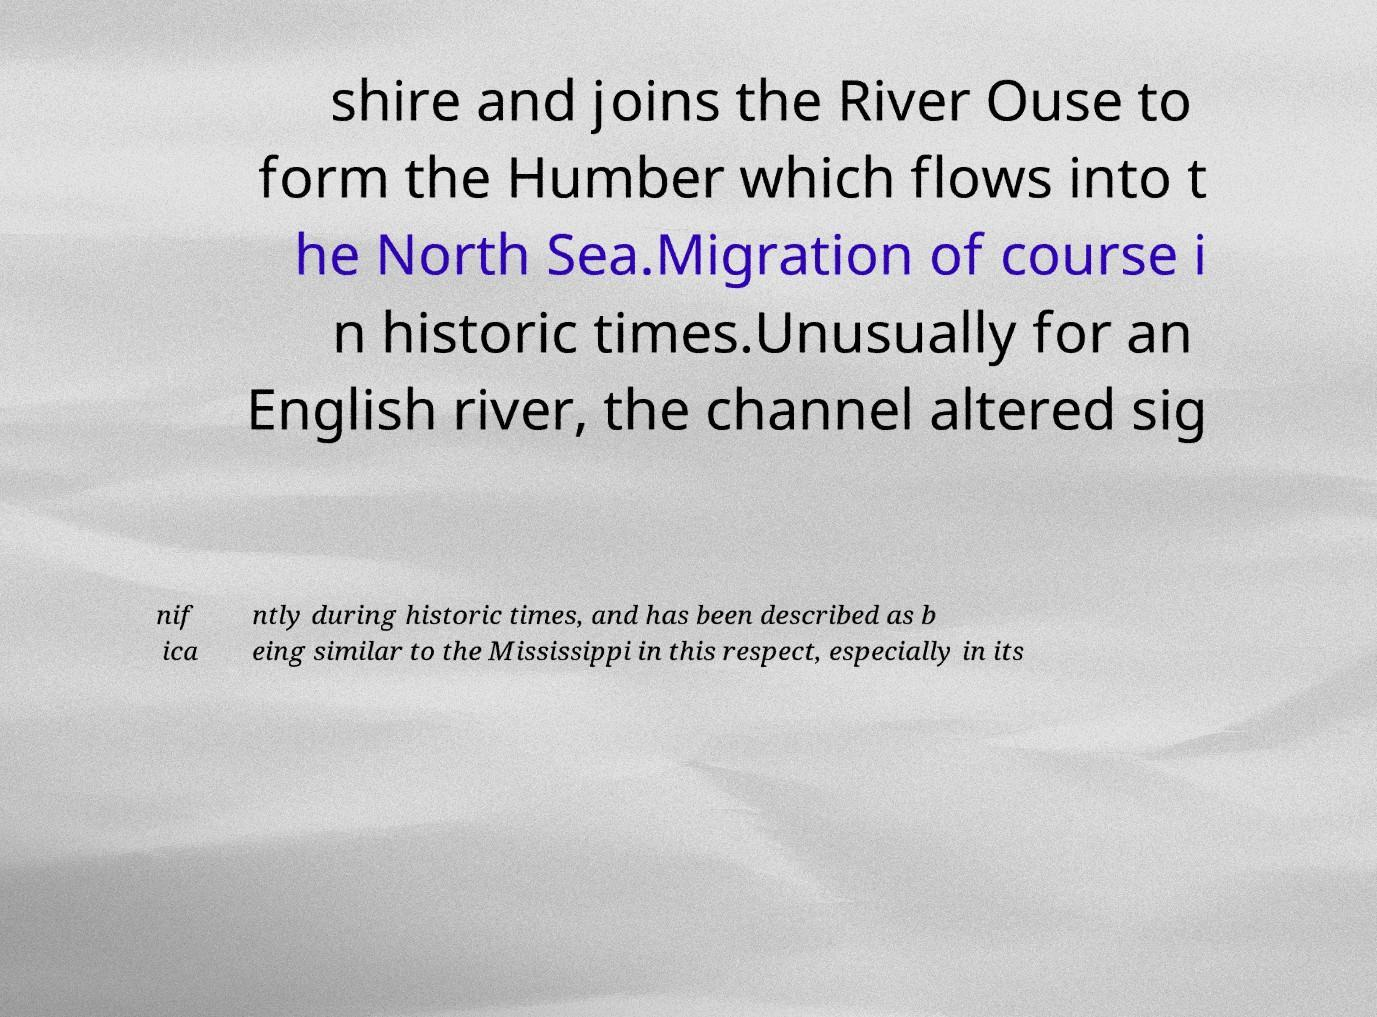Could you extract and type out the text from this image? shire and joins the River Ouse to form the Humber which flows into t he North Sea.Migration of course i n historic times.Unusually for an English river, the channel altered sig nif ica ntly during historic times, and has been described as b eing similar to the Mississippi in this respect, especially in its 